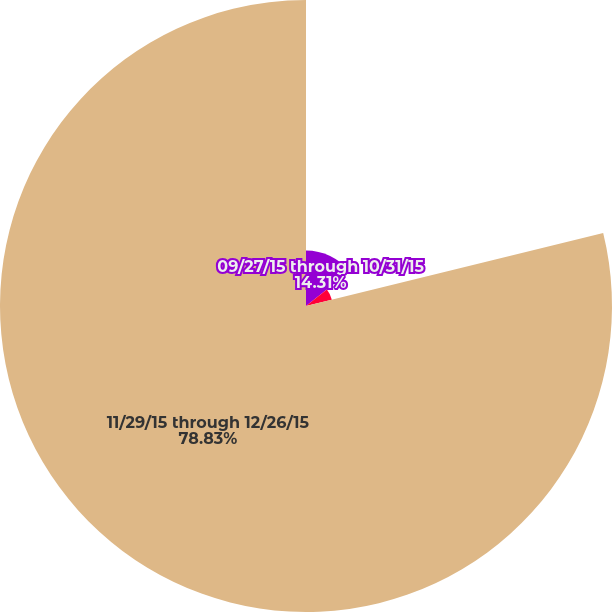Convert chart to OTSL. <chart><loc_0><loc_0><loc_500><loc_500><pie_chart><fcel>09/27/15 through 10/31/15<fcel>11/01/15 through 11/28/15<fcel>11/29/15 through 12/26/15<nl><fcel>14.31%<fcel>6.86%<fcel>78.82%<nl></chart> 